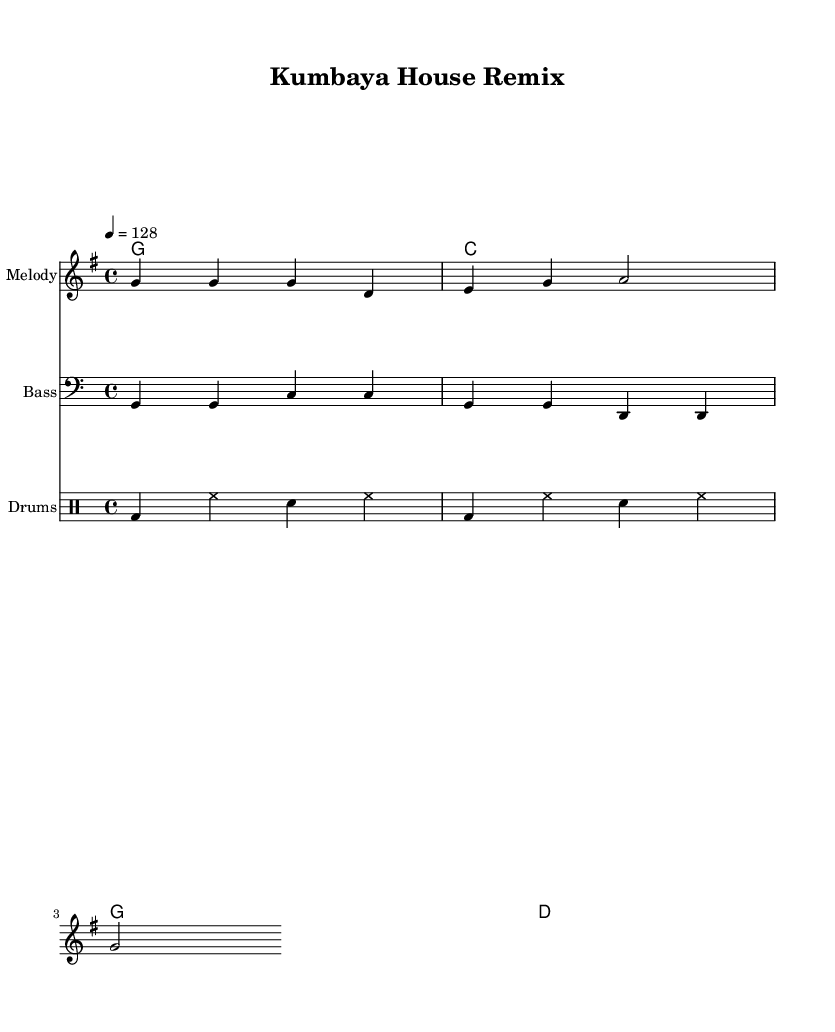What is the key signature of this music? The key signature is G major, indicated by one sharp (F#) at the beginning of the staff.
Answer: G major What is the time signature of the piece? The time signature is shown as 4/4, which means there are four beats in each measure and a quarter note gets one beat.
Answer: 4/4 What is the tempo marking for this piece? The tempo is marked as 128 beats per minute, indicating the speed at which the piece should be played.
Answer: 128 How many measures are in the melody? By counting the measures laid out in the melody section, we can see there are four measures total.
Answer: 4 measures Which instrument plays the melody? The staff labeled "Melody" indicates that this line is meant for the primary melody instrument, often a higher-pitched instrument or voice.
Answer: Melody What is the chord progression used in this remix? The chord progression can be read from the ChordNames staff, showing the sequence G, C, G, D.
Answer: G, C, G, D What genres influence this arrangement of the song? The genre is House music, which often incorporates electronic elements and a beat for dancing, as seen in the drum pattern.
Answer: House 